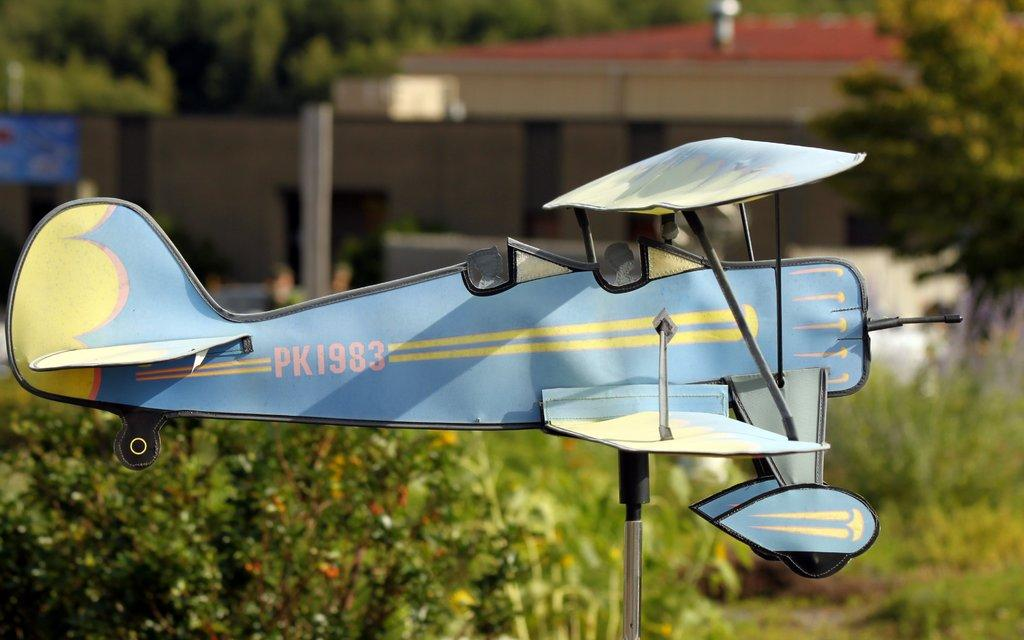<image>
Present a compact description of the photo's key features. A model plane that's blue and yellow with PK1983 on it. 